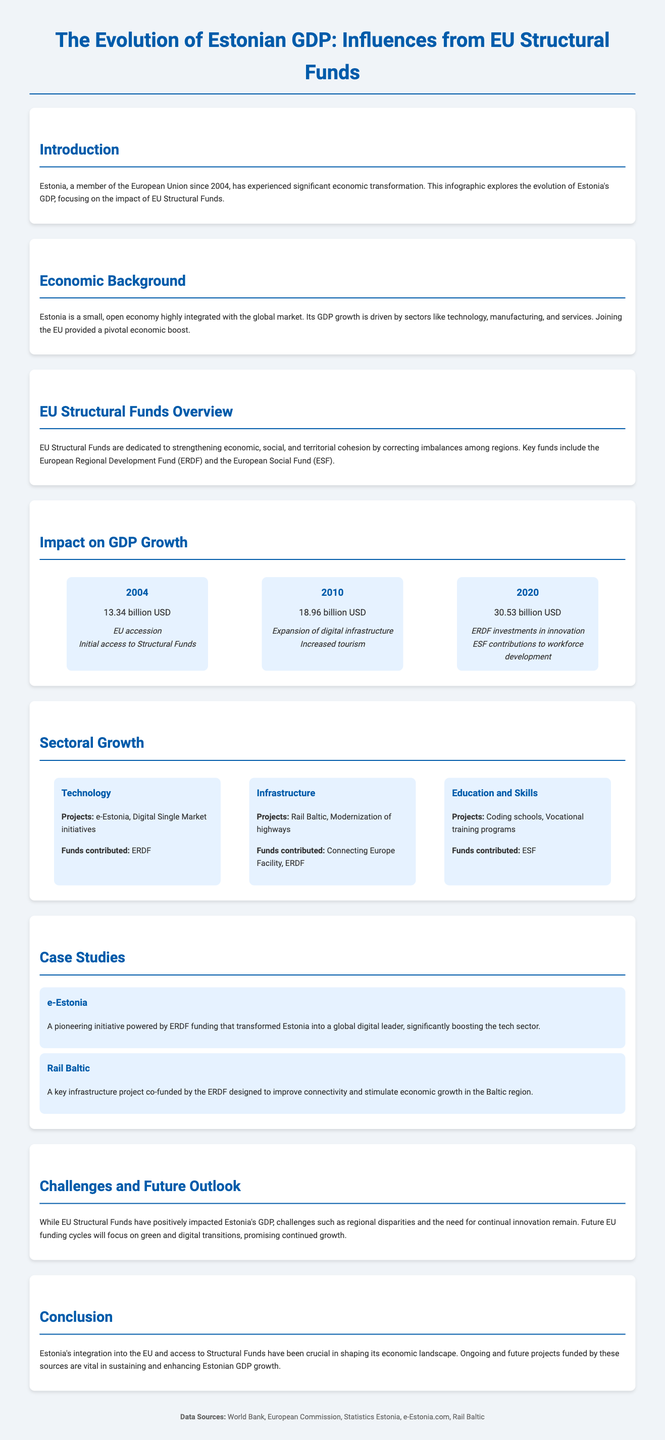What year did Estonia join the EU? Estonia became a member of the European Union in 2004.
Answer: 2004 What was Estonia's GDP in 2020? The document states that Estonia's GDP in 2020 was 30.53 billion USD.
Answer: 30.53 billion USD Which fund contributed to the e-Estonia project? The e-Estonia initiative was powered by ERDF funding.
Answer: ERDF What influence was noted for GDP growth in 2010? The document mentions the expansion of digital infrastructure and increased tourism as influences on GDP growth in 2010.
Answer: Expansion of digital infrastructure, Increased tourism What are the main sectors driving Estonia's GDP growth? The document identifies technology, manufacturing, and services as key sectors driving GDP growth.
Answer: Technology, manufacturing, and services What project is associated with improving connectivity in the Baltic region? Rail Baltic is a key infrastructure project associated with improving connectivity.
Answer: Rail Baltic What type of funds are aimed at correcting regional imbalances? EU Structural Funds are designed to strengthen economic, social, and territorial cohesion by correcting regional imbalances.
Answer: EU Structural Funds What future focus will EU funding cycles have according to the document? Future EU funding cycles will focus on green and digital transitions.
Answer: Green and digital transitions 